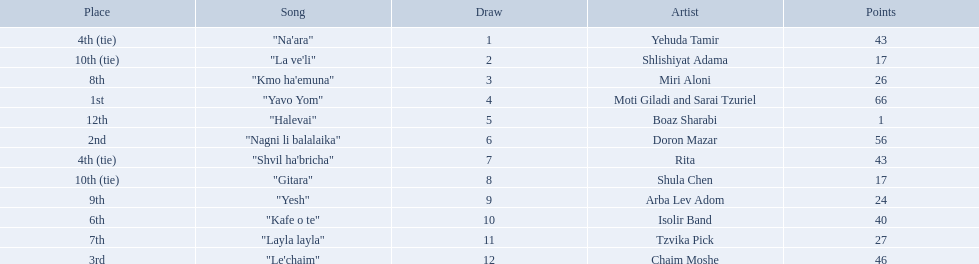What is the place of the contestant who received only 1 point? 12th. What is the name of the artist listed in the previous question? Boaz Sharabi. 